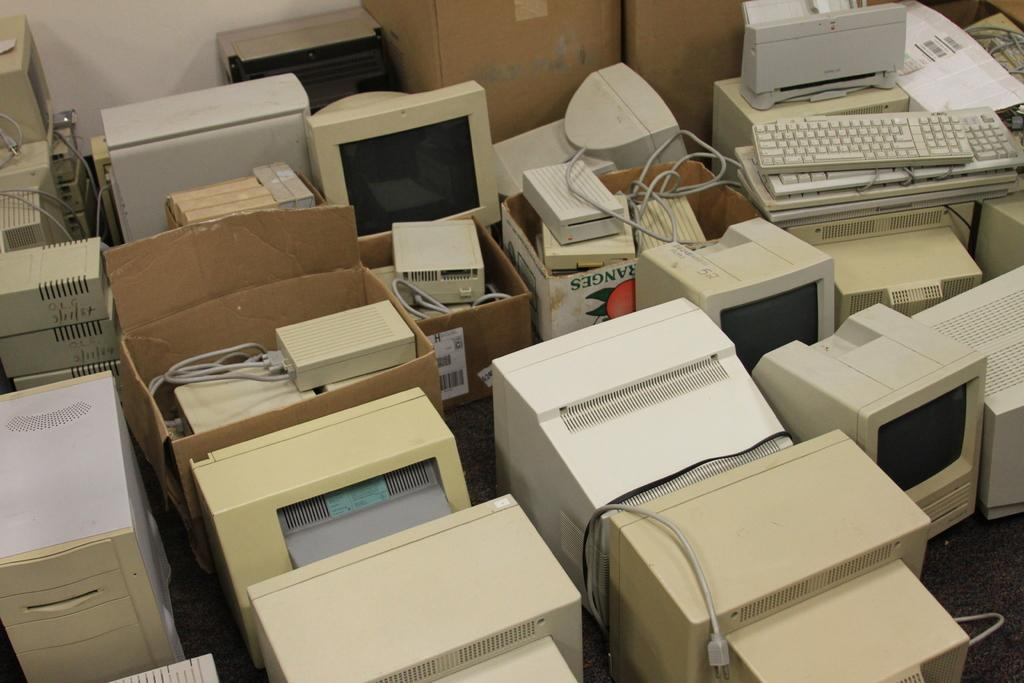What electronic devices are present in the image? There are computers in the image. What type of storage containers can be seen in the image? There are carton boxes in the image. What are the computers connected to in the image? There are keyboards in the image, which are connected to the computers. Is there a fight happening between the computers in the image? No, there is no fight happening between the computers in the image. What type of steel is used to construct the keyboards in the image? The provided facts do not mention the type of steel used in the keyboards, and there is no indication of steel in the image. 